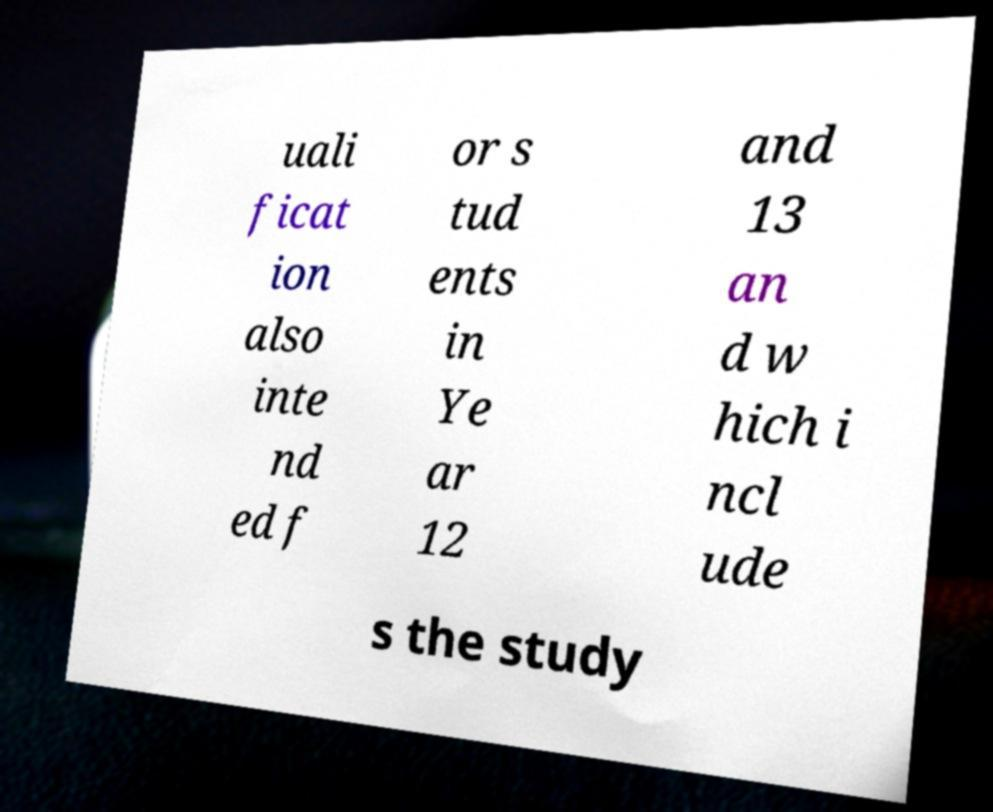For documentation purposes, I need the text within this image transcribed. Could you provide that? uali ficat ion also inte nd ed f or s tud ents in Ye ar 12 and 13 an d w hich i ncl ude s the study 